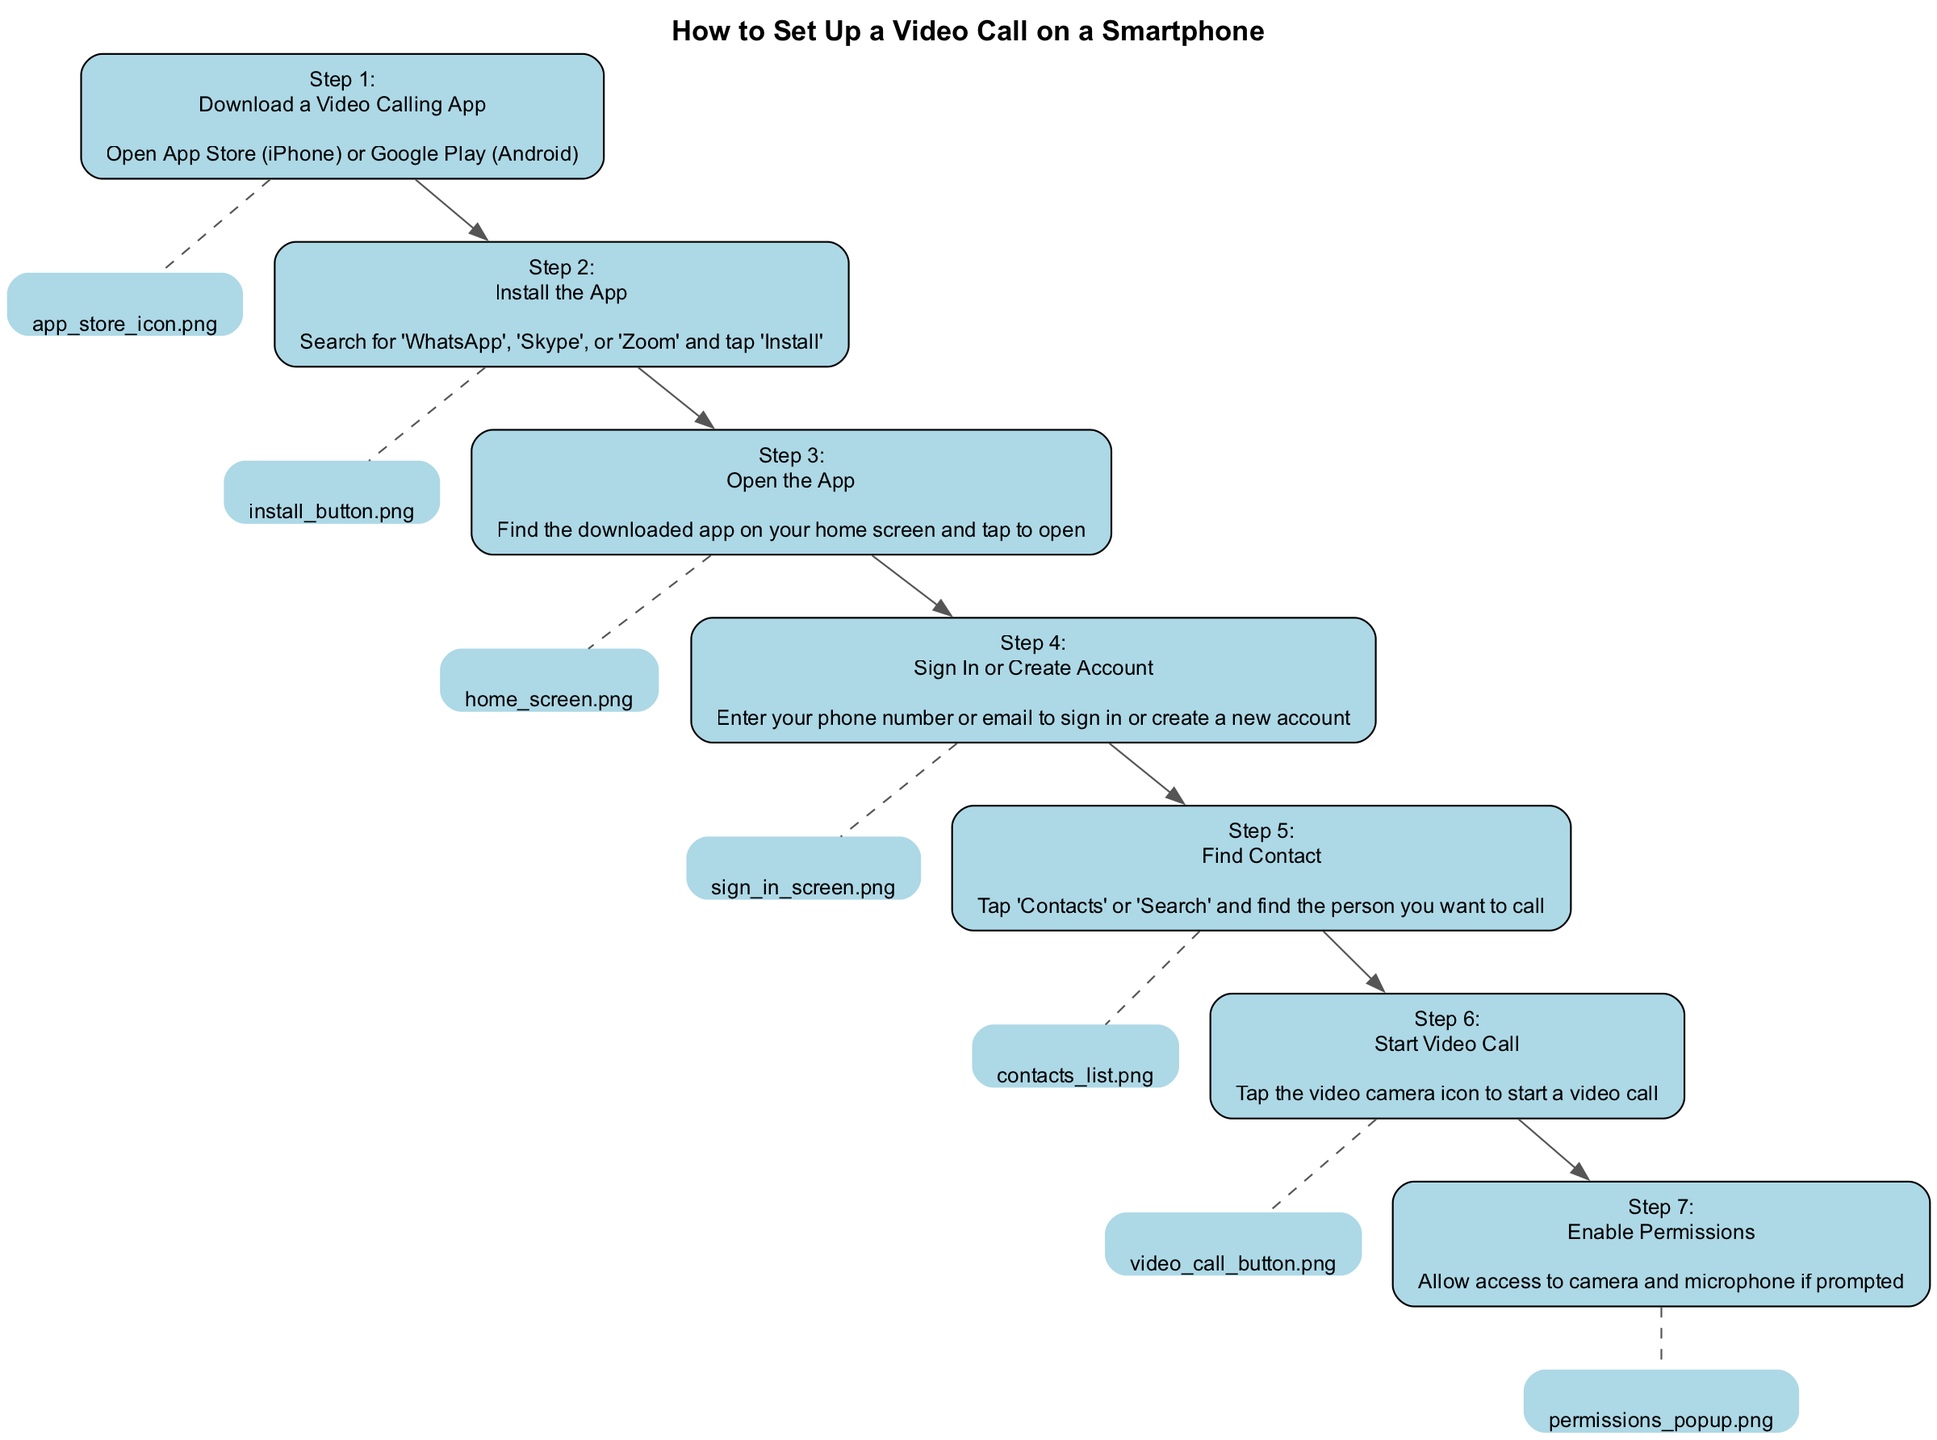What is the first step in setting up a video call? The first step listed in the diagram is downloading a video calling app, which is clearly stated as the title of the first step.
Answer: Download a Video Calling App How many steps are in the diagram? By counting the number of individual steps presented in the diagram, we can see there are a total of seven steps describing the process.
Answer: 7 What is the visual cue for the 'Sign In or Create Account' step? The visual cue associated with the 'Sign In or Create Account' step, which is the fourth step, is the image labeled 'sign_in_screen.png'. This is indicated as the visual representation connected to that particular step.
Answer: sign_in_screen.png What do you need to allow when prompted? The diagram states that you need to enable permissions to allow access to the camera and microphone when prompted, which is part of the last step.
Answer: Access to camera and microphone Which step comes after finding a contact? The step that follows 'Find Contact', which is the fifth step, is 'Start Video Call', as the arrows connecting the steps indicate the sequence in which they occur.
Answer: Start Video Call What app options are provided in the installation step? The options provided in the second step for installing are 'WhatsApp', 'Skype', or 'Zoom', which are explicitly mentioned in the description of that step.
Answer: WhatsApp, Skype, Zoom How does one start a video call? To start a video call, the diagram instructs to tap the video camera icon, which is the action described in the sixth step of the diagram.
Answer: Tap the video camera icon Which step requires you to tap on 'Contacts'? The step that requires tapping on 'Contacts' is the fifth step, clearly stating that action in its description for finding a person to call.
Answer: Find Contact 